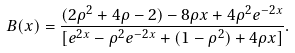<formula> <loc_0><loc_0><loc_500><loc_500>B ( x ) = \frac { ( 2 \rho ^ { 2 } + 4 \rho - 2 ) - 8 \rho x + 4 \rho ^ { 2 } e ^ { - 2 x } } { [ e ^ { 2 x } - \rho ^ { 2 } e ^ { - 2 x } + ( 1 - \rho ^ { 2 } ) + 4 \rho x ] } .</formula> 